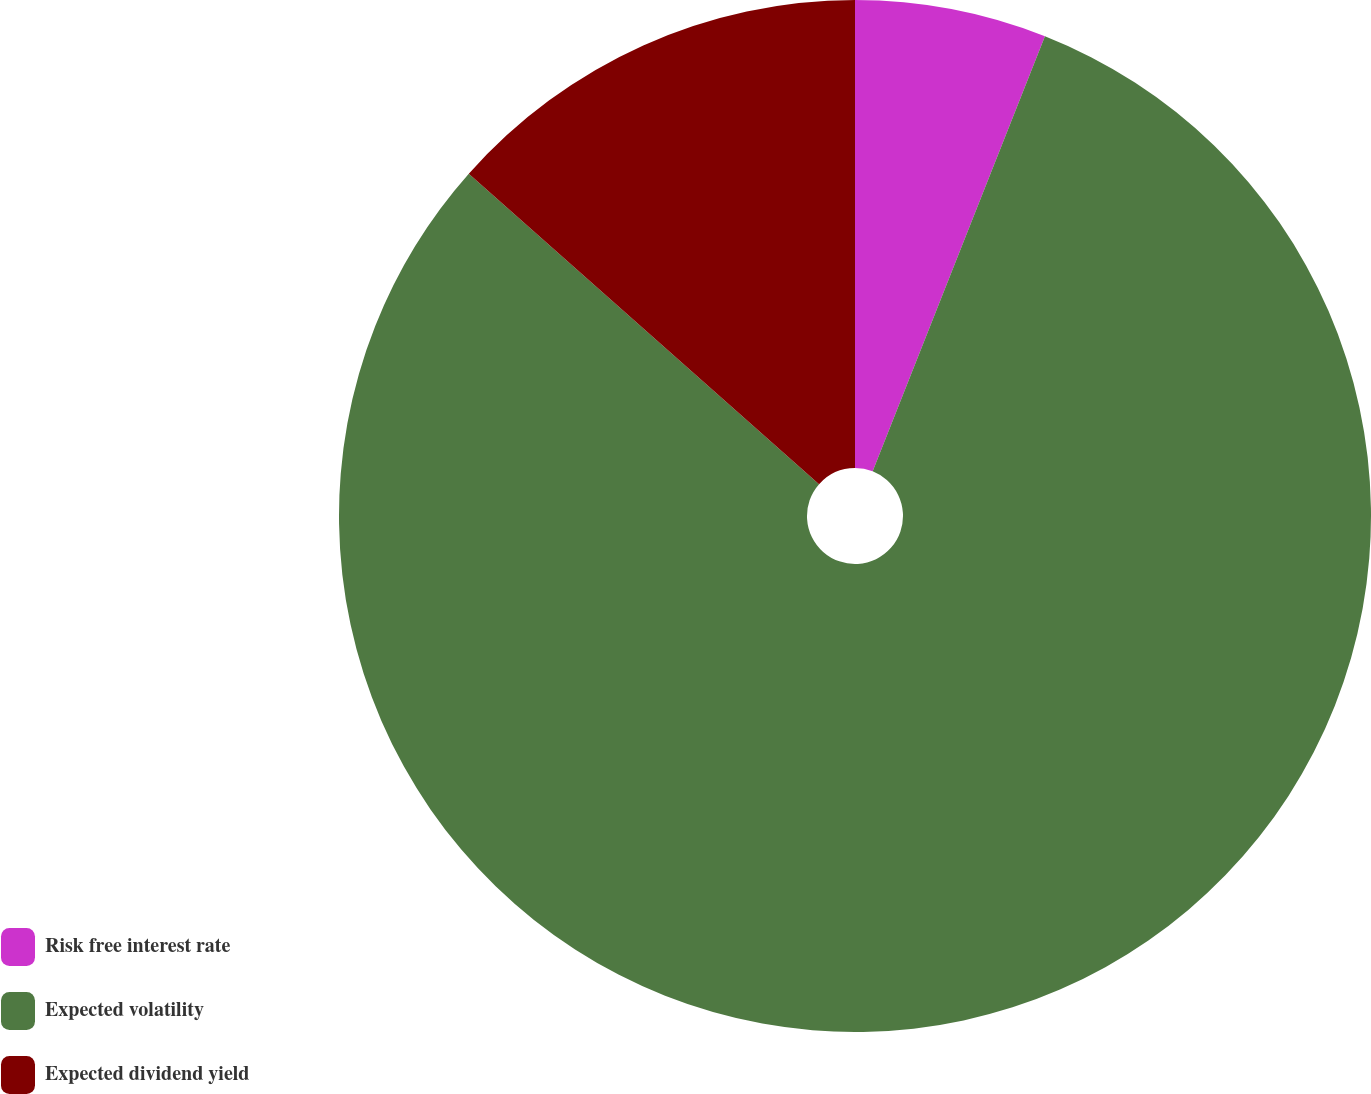Convert chart to OTSL. <chart><loc_0><loc_0><loc_500><loc_500><pie_chart><fcel>Risk free interest rate<fcel>Expected volatility<fcel>Expected dividend yield<nl><fcel>6.0%<fcel>80.54%<fcel>13.46%<nl></chart> 